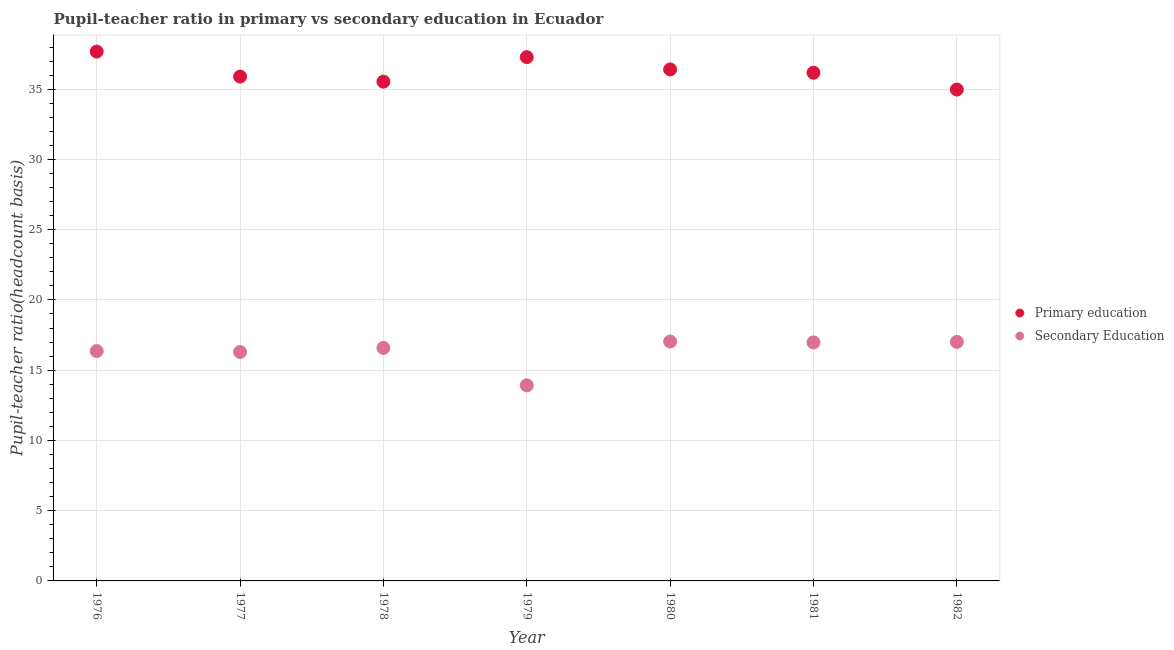Is the number of dotlines equal to the number of legend labels?
Keep it short and to the point. Yes. What is the pupil teacher ratio on secondary education in 1980?
Keep it short and to the point. 17.04. Across all years, what is the maximum pupil teacher ratio on secondary education?
Provide a short and direct response. 17.04. Across all years, what is the minimum pupil-teacher ratio in primary education?
Your response must be concise. 34.98. In which year was the pupil-teacher ratio in primary education maximum?
Offer a very short reply. 1976. In which year was the pupil teacher ratio on secondary education minimum?
Provide a short and direct response. 1979. What is the total pupil teacher ratio on secondary education in the graph?
Make the answer very short. 114.19. What is the difference between the pupil-teacher ratio in primary education in 1977 and that in 1980?
Ensure brevity in your answer.  -0.51. What is the difference between the pupil-teacher ratio in primary education in 1976 and the pupil teacher ratio on secondary education in 1977?
Offer a very short reply. 21.38. What is the average pupil-teacher ratio in primary education per year?
Offer a very short reply. 36.28. In the year 1982, what is the difference between the pupil teacher ratio on secondary education and pupil-teacher ratio in primary education?
Provide a succinct answer. -17.96. What is the ratio of the pupil teacher ratio on secondary education in 1977 to that in 1980?
Offer a very short reply. 0.96. What is the difference between the highest and the second highest pupil teacher ratio on secondary education?
Offer a very short reply. 0.02. What is the difference between the highest and the lowest pupil teacher ratio on secondary education?
Ensure brevity in your answer.  3.12. In how many years, is the pupil-teacher ratio in primary education greater than the average pupil-teacher ratio in primary education taken over all years?
Your answer should be very brief. 3. Is the sum of the pupil teacher ratio on secondary education in 1977 and 1978 greater than the maximum pupil-teacher ratio in primary education across all years?
Offer a terse response. No. Does the pupil-teacher ratio in primary education monotonically increase over the years?
Your answer should be compact. No. Is the pupil teacher ratio on secondary education strictly greater than the pupil-teacher ratio in primary education over the years?
Offer a terse response. No. Is the pupil teacher ratio on secondary education strictly less than the pupil-teacher ratio in primary education over the years?
Your answer should be very brief. Yes. How many dotlines are there?
Provide a short and direct response. 2. What is the difference between two consecutive major ticks on the Y-axis?
Give a very brief answer. 5. Are the values on the major ticks of Y-axis written in scientific E-notation?
Provide a short and direct response. No. How many legend labels are there?
Ensure brevity in your answer.  2. What is the title of the graph?
Your answer should be compact. Pupil-teacher ratio in primary vs secondary education in Ecuador. What is the label or title of the X-axis?
Your answer should be compact. Year. What is the label or title of the Y-axis?
Ensure brevity in your answer.  Pupil-teacher ratio(headcount basis). What is the Pupil-teacher ratio(headcount basis) in Primary education in 1976?
Keep it short and to the point. 37.68. What is the Pupil-teacher ratio(headcount basis) in Secondary Education in 1976?
Provide a short and direct response. 16.36. What is the Pupil-teacher ratio(headcount basis) in Primary education in 1977?
Give a very brief answer. 35.9. What is the Pupil-teacher ratio(headcount basis) of Secondary Education in 1977?
Provide a short and direct response. 16.29. What is the Pupil-teacher ratio(headcount basis) of Primary education in 1978?
Your answer should be very brief. 35.54. What is the Pupil-teacher ratio(headcount basis) of Secondary Education in 1978?
Provide a succinct answer. 16.58. What is the Pupil-teacher ratio(headcount basis) in Primary education in 1979?
Provide a short and direct response. 37.28. What is the Pupil-teacher ratio(headcount basis) in Secondary Education in 1979?
Offer a terse response. 13.92. What is the Pupil-teacher ratio(headcount basis) of Primary education in 1980?
Provide a short and direct response. 36.41. What is the Pupil-teacher ratio(headcount basis) in Secondary Education in 1980?
Keep it short and to the point. 17.04. What is the Pupil-teacher ratio(headcount basis) in Primary education in 1981?
Make the answer very short. 36.17. What is the Pupil-teacher ratio(headcount basis) in Secondary Education in 1981?
Offer a very short reply. 16.98. What is the Pupil-teacher ratio(headcount basis) of Primary education in 1982?
Offer a very short reply. 34.98. What is the Pupil-teacher ratio(headcount basis) of Secondary Education in 1982?
Offer a terse response. 17.01. Across all years, what is the maximum Pupil-teacher ratio(headcount basis) of Primary education?
Provide a succinct answer. 37.68. Across all years, what is the maximum Pupil-teacher ratio(headcount basis) of Secondary Education?
Ensure brevity in your answer.  17.04. Across all years, what is the minimum Pupil-teacher ratio(headcount basis) in Primary education?
Your answer should be very brief. 34.98. Across all years, what is the minimum Pupil-teacher ratio(headcount basis) in Secondary Education?
Provide a short and direct response. 13.92. What is the total Pupil-teacher ratio(headcount basis) of Primary education in the graph?
Make the answer very short. 253.95. What is the total Pupil-teacher ratio(headcount basis) of Secondary Education in the graph?
Offer a terse response. 114.19. What is the difference between the Pupil-teacher ratio(headcount basis) in Primary education in 1976 and that in 1977?
Give a very brief answer. 1.78. What is the difference between the Pupil-teacher ratio(headcount basis) of Secondary Education in 1976 and that in 1977?
Make the answer very short. 0.07. What is the difference between the Pupil-teacher ratio(headcount basis) of Primary education in 1976 and that in 1978?
Provide a short and direct response. 2.14. What is the difference between the Pupil-teacher ratio(headcount basis) in Secondary Education in 1976 and that in 1978?
Your answer should be compact. -0.22. What is the difference between the Pupil-teacher ratio(headcount basis) of Primary education in 1976 and that in 1979?
Keep it short and to the point. 0.4. What is the difference between the Pupil-teacher ratio(headcount basis) of Secondary Education in 1976 and that in 1979?
Your response must be concise. 2.44. What is the difference between the Pupil-teacher ratio(headcount basis) of Primary education in 1976 and that in 1980?
Provide a succinct answer. 1.27. What is the difference between the Pupil-teacher ratio(headcount basis) in Secondary Education in 1976 and that in 1980?
Offer a terse response. -0.68. What is the difference between the Pupil-teacher ratio(headcount basis) in Primary education in 1976 and that in 1981?
Your response must be concise. 1.51. What is the difference between the Pupil-teacher ratio(headcount basis) of Secondary Education in 1976 and that in 1981?
Provide a short and direct response. -0.62. What is the difference between the Pupil-teacher ratio(headcount basis) of Primary education in 1976 and that in 1982?
Your answer should be compact. 2.7. What is the difference between the Pupil-teacher ratio(headcount basis) in Secondary Education in 1976 and that in 1982?
Ensure brevity in your answer.  -0.65. What is the difference between the Pupil-teacher ratio(headcount basis) of Primary education in 1977 and that in 1978?
Make the answer very short. 0.36. What is the difference between the Pupil-teacher ratio(headcount basis) of Secondary Education in 1977 and that in 1978?
Offer a terse response. -0.29. What is the difference between the Pupil-teacher ratio(headcount basis) in Primary education in 1977 and that in 1979?
Keep it short and to the point. -1.38. What is the difference between the Pupil-teacher ratio(headcount basis) of Secondary Education in 1977 and that in 1979?
Your answer should be compact. 2.38. What is the difference between the Pupil-teacher ratio(headcount basis) of Primary education in 1977 and that in 1980?
Your answer should be compact. -0.51. What is the difference between the Pupil-teacher ratio(headcount basis) of Secondary Education in 1977 and that in 1980?
Offer a terse response. -0.74. What is the difference between the Pupil-teacher ratio(headcount basis) of Primary education in 1977 and that in 1981?
Provide a short and direct response. -0.27. What is the difference between the Pupil-teacher ratio(headcount basis) of Secondary Education in 1977 and that in 1981?
Make the answer very short. -0.68. What is the difference between the Pupil-teacher ratio(headcount basis) in Primary education in 1977 and that in 1982?
Give a very brief answer. 0.92. What is the difference between the Pupil-teacher ratio(headcount basis) in Secondary Education in 1977 and that in 1982?
Your answer should be very brief. -0.72. What is the difference between the Pupil-teacher ratio(headcount basis) of Primary education in 1978 and that in 1979?
Ensure brevity in your answer.  -1.74. What is the difference between the Pupil-teacher ratio(headcount basis) in Secondary Education in 1978 and that in 1979?
Ensure brevity in your answer.  2.67. What is the difference between the Pupil-teacher ratio(headcount basis) of Primary education in 1978 and that in 1980?
Provide a short and direct response. -0.87. What is the difference between the Pupil-teacher ratio(headcount basis) in Secondary Education in 1978 and that in 1980?
Give a very brief answer. -0.45. What is the difference between the Pupil-teacher ratio(headcount basis) in Primary education in 1978 and that in 1981?
Provide a succinct answer. -0.64. What is the difference between the Pupil-teacher ratio(headcount basis) in Secondary Education in 1978 and that in 1981?
Provide a succinct answer. -0.39. What is the difference between the Pupil-teacher ratio(headcount basis) in Primary education in 1978 and that in 1982?
Offer a terse response. 0.56. What is the difference between the Pupil-teacher ratio(headcount basis) of Secondary Education in 1978 and that in 1982?
Ensure brevity in your answer.  -0.43. What is the difference between the Pupil-teacher ratio(headcount basis) in Primary education in 1979 and that in 1980?
Make the answer very short. 0.87. What is the difference between the Pupil-teacher ratio(headcount basis) of Secondary Education in 1979 and that in 1980?
Give a very brief answer. -3.12. What is the difference between the Pupil-teacher ratio(headcount basis) in Primary education in 1979 and that in 1981?
Your response must be concise. 1.11. What is the difference between the Pupil-teacher ratio(headcount basis) of Secondary Education in 1979 and that in 1981?
Provide a short and direct response. -3.06. What is the difference between the Pupil-teacher ratio(headcount basis) of Primary education in 1979 and that in 1982?
Your answer should be very brief. 2.3. What is the difference between the Pupil-teacher ratio(headcount basis) of Secondary Education in 1979 and that in 1982?
Ensure brevity in your answer.  -3.09. What is the difference between the Pupil-teacher ratio(headcount basis) of Primary education in 1980 and that in 1981?
Offer a terse response. 0.23. What is the difference between the Pupil-teacher ratio(headcount basis) in Secondary Education in 1980 and that in 1981?
Your response must be concise. 0.06. What is the difference between the Pupil-teacher ratio(headcount basis) in Primary education in 1980 and that in 1982?
Offer a terse response. 1.43. What is the difference between the Pupil-teacher ratio(headcount basis) in Secondary Education in 1980 and that in 1982?
Provide a succinct answer. 0.02. What is the difference between the Pupil-teacher ratio(headcount basis) in Primary education in 1981 and that in 1982?
Keep it short and to the point. 1.2. What is the difference between the Pupil-teacher ratio(headcount basis) of Secondary Education in 1981 and that in 1982?
Ensure brevity in your answer.  -0.04. What is the difference between the Pupil-teacher ratio(headcount basis) of Primary education in 1976 and the Pupil-teacher ratio(headcount basis) of Secondary Education in 1977?
Provide a succinct answer. 21.38. What is the difference between the Pupil-teacher ratio(headcount basis) in Primary education in 1976 and the Pupil-teacher ratio(headcount basis) in Secondary Education in 1978?
Give a very brief answer. 21.09. What is the difference between the Pupil-teacher ratio(headcount basis) of Primary education in 1976 and the Pupil-teacher ratio(headcount basis) of Secondary Education in 1979?
Your answer should be compact. 23.76. What is the difference between the Pupil-teacher ratio(headcount basis) of Primary education in 1976 and the Pupil-teacher ratio(headcount basis) of Secondary Education in 1980?
Keep it short and to the point. 20.64. What is the difference between the Pupil-teacher ratio(headcount basis) in Primary education in 1976 and the Pupil-teacher ratio(headcount basis) in Secondary Education in 1981?
Provide a short and direct response. 20.7. What is the difference between the Pupil-teacher ratio(headcount basis) of Primary education in 1976 and the Pupil-teacher ratio(headcount basis) of Secondary Education in 1982?
Offer a very short reply. 20.66. What is the difference between the Pupil-teacher ratio(headcount basis) of Primary education in 1977 and the Pupil-teacher ratio(headcount basis) of Secondary Education in 1978?
Offer a very short reply. 19.31. What is the difference between the Pupil-teacher ratio(headcount basis) in Primary education in 1977 and the Pupil-teacher ratio(headcount basis) in Secondary Education in 1979?
Give a very brief answer. 21.98. What is the difference between the Pupil-teacher ratio(headcount basis) of Primary education in 1977 and the Pupil-teacher ratio(headcount basis) of Secondary Education in 1980?
Your answer should be compact. 18.86. What is the difference between the Pupil-teacher ratio(headcount basis) of Primary education in 1977 and the Pupil-teacher ratio(headcount basis) of Secondary Education in 1981?
Your answer should be compact. 18.92. What is the difference between the Pupil-teacher ratio(headcount basis) of Primary education in 1977 and the Pupil-teacher ratio(headcount basis) of Secondary Education in 1982?
Your answer should be very brief. 18.88. What is the difference between the Pupil-teacher ratio(headcount basis) of Primary education in 1978 and the Pupil-teacher ratio(headcount basis) of Secondary Education in 1979?
Your response must be concise. 21.62. What is the difference between the Pupil-teacher ratio(headcount basis) in Primary education in 1978 and the Pupil-teacher ratio(headcount basis) in Secondary Education in 1980?
Your answer should be very brief. 18.5. What is the difference between the Pupil-teacher ratio(headcount basis) in Primary education in 1978 and the Pupil-teacher ratio(headcount basis) in Secondary Education in 1981?
Ensure brevity in your answer.  18.56. What is the difference between the Pupil-teacher ratio(headcount basis) of Primary education in 1978 and the Pupil-teacher ratio(headcount basis) of Secondary Education in 1982?
Offer a terse response. 18.52. What is the difference between the Pupil-teacher ratio(headcount basis) in Primary education in 1979 and the Pupil-teacher ratio(headcount basis) in Secondary Education in 1980?
Ensure brevity in your answer.  20.24. What is the difference between the Pupil-teacher ratio(headcount basis) of Primary education in 1979 and the Pupil-teacher ratio(headcount basis) of Secondary Education in 1981?
Offer a terse response. 20.3. What is the difference between the Pupil-teacher ratio(headcount basis) of Primary education in 1979 and the Pupil-teacher ratio(headcount basis) of Secondary Education in 1982?
Offer a terse response. 20.27. What is the difference between the Pupil-teacher ratio(headcount basis) of Primary education in 1980 and the Pupil-teacher ratio(headcount basis) of Secondary Education in 1981?
Provide a succinct answer. 19.43. What is the difference between the Pupil-teacher ratio(headcount basis) in Primary education in 1980 and the Pupil-teacher ratio(headcount basis) in Secondary Education in 1982?
Provide a succinct answer. 19.39. What is the difference between the Pupil-teacher ratio(headcount basis) of Primary education in 1981 and the Pupil-teacher ratio(headcount basis) of Secondary Education in 1982?
Ensure brevity in your answer.  19.16. What is the average Pupil-teacher ratio(headcount basis) in Primary education per year?
Offer a very short reply. 36.28. What is the average Pupil-teacher ratio(headcount basis) in Secondary Education per year?
Your response must be concise. 16.31. In the year 1976, what is the difference between the Pupil-teacher ratio(headcount basis) of Primary education and Pupil-teacher ratio(headcount basis) of Secondary Education?
Provide a succinct answer. 21.32. In the year 1977, what is the difference between the Pupil-teacher ratio(headcount basis) of Primary education and Pupil-teacher ratio(headcount basis) of Secondary Education?
Provide a short and direct response. 19.6. In the year 1978, what is the difference between the Pupil-teacher ratio(headcount basis) in Primary education and Pupil-teacher ratio(headcount basis) in Secondary Education?
Offer a terse response. 18.95. In the year 1979, what is the difference between the Pupil-teacher ratio(headcount basis) of Primary education and Pupil-teacher ratio(headcount basis) of Secondary Education?
Provide a short and direct response. 23.36. In the year 1980, what is the difference between the Pupil-teacher ratio(headcount basis) in Primary education and Pupil-teacher ratio(headcount basis) in Secondary Education?
Offer a very short reply. 19.37. In the year 1981, what is the difference between the Pupil-teacher ratio(headcount basis) in Primary education and Pupil-teacher ratio(headcount basis) in Secondary Education?
Your response must be concise. 19.2. In the year 1982, what is the difference between the Pupil-teacher ratio(headcount basis) of Primary education and Pupil-teacher ratio(headcount basis) of Secondary Education?
Offer a terse response. 17.96. What is the ratio of the Pupil-teacher ratio(headcount basis) in Primary education in 1976 to that in 1977?
Ensure brevity in your answer.  1.05. What is the ratio of the Pupil-teacher ratio(headcount basis) in Primary education in 1976 to that in 1978?
Give a very brief answer. 1.06. What is the ratio of the Pupil-teacher ratio(headcount basis) of Secondary Education in 1976 to that in 1978?
Give a very brief answer. 0.99. What is the ratio of the Pupil-teacher ratio(headcount basis) of Primary education in 1976 to that in 1979?
Your response must be concise. 1.01. What is the ratio of the Pupil-teacher ratio(headcount basis) in Secondary Education in 1976 to that in 1979?
Your answer should be compact. 1.18. What is the ratio of the Pupil-teacher ratio(headcount basis) of Primary education in 1976 to that in 1980?
Make the answer very short. 1.03. What is the ratio of the Pupil-teacher ratio(headcount basis) of Secondary Education in 1976 to that in 1980?
Offer a very short reply. 0.96. What is the ratio of the Pupil-teacher ratio(headcount basis) of Primary education in 1976 to that in 1981?
Your answer should be very brief. 1.04. What is the ratio of the Pupil-teacher ratio(headcount basis) of Secondary Education in 1976 to that in 1981?
Your answer should be compact. 0.96. What is the ratio of the Pupil-teacher ratio(headcount basis) of Primary education in 1976 to that in 1982?
Offer a terse response. 1.08. What is the ratio of the Pupil-teacher ratio(headcount basis) in Secondary Education in 1976 to that in 1982?
Your answer should be very brief. 0.96. What is the ratio of the Pupil-teacher ratio(headcount basis) of Primary education in 1977 to that in 1978?
Offer a terse response. 1.01. What is the ratio of the Pupil-teacher ratio(headcount basis) of Secondary Education in 1977 to that in 1978?
Make the answer very short. 0.98. What is the ratio of the Pupil-teacher ratio(headcount basis) in Primary education in 1977 to that in 1979?
Make the answer very short. 0.96. What is the ratio of the Pupil-teacher ratio(headcount basis) in Secondary Education in 1977 to that in 1979?
Ensure brevity in your answer.  1.17. What is the ratio of the Pupil-teacher ratio(headcount basis) in Primary education in 1977 to that in 1980?
Provide a succinct answer. 0.99. What is the ratio of the Pupil-teacher ratio(headcount basis) of Secondary Education in 1977 to that in 1980?
Keep it short and to the point. 0.96. What is the ratio of the Pupil-teacher ratio(headcount basis) of Primary education in 1977 to that in 1981?
Your answer should be very brief. 0.99. What is the ratio of the Pupil-teacher ratio(headcount basis) of Secondary Education in 1977 to that in 1981?
Provide a short and direct response. 0.96. What is the ratio of the Pupil-teacher ratio(headcount basis) in Primary education in 1977 to that in 1982?
Give a very brief answer. 1.03. What is the ratio of the Pupil-teacher ratio(headcount basis) in Secondary Education in 1977 to that in 1982?
Provide a succinct answer. 0.96. What is the ratio of the Pupil-teacher ratio(headcount basis) in Primary education in 1978 to that in 1979?
Make the answer very short. 0.95. What is the ratio of the Pupil-teacher ratio(headcount basis) in Secondary Education in 1978 to that in 1979?
Your answer should be compact. 1.19. What is the ratio of the Pupil-teacher ratio(headcount basis) of Primary education in 1978 to that in 1980?
Give a very brief answer. 0.98. What is the ratio of the Pupil-teacher ratio(headcount basis) of Secondary Education in 1978 to that in 1980?
Your answer should be very brief. 0.97. What is the ratio of the Pupil-teacher ratio(headcount basis) of Primary education in 1978 to that in 1981?
Ensure brevity in your answer.  0.98. What is the ratio of the Pupil-teacher ratio(headcount basis) in Secondary Education in 1978 to that in 1981?
Keep it short and to the point. 0.98. What is the ratio of the Pupil-teacher ratio(headcount basis) in Primary education in 1978 to that in 1982?
Offer a very short reply. 1.02. What is the ratio of the Pupil-teacher ratio(headcount basis) in Secondary Education in 1978 to that in 1982?
Keep it short and to the point. 0.97. What is the ratio of the Pupil-teacher ratio(headcount basis) of Primary education in 1979 to that in 1980?
Offer a terse response. 1.02. What is the ratio of the Pupil-teacher ratio(headcount basis) of Secondary Education in 1979 to that in 1980?
Give a very brief answer. 0.82. What is the ratio of the Pupil-teacher ratio(headcount basis) of Primary education in 1979 to that in 1981?
Offer a very short reply. 1.03. What is the ratio of the Pupil-teacher ratio(headcount basis) in Secondary Education in 1979 to that in 1981?
Ensure brevity in your answer.  0.82. What is the ratio of the Pupil-teacher ratio(headcount basis) of Primary education in 1979 to that in 1982?
Your response must be concise. 1.07. What is the ratio of the Pupil-teacher ratio(headcount basis) of Secondary Education in 1979 to that in 1982?
Your response must be concise. 0.82. What is the ratio of the Pupil-teacher ratio(headcount basis) of Primary education in 1980 to that in 1981?
Make the answer very short. 1.01. What is the ratio of the Pupil-teacher ratio(headcount basis) of Secondary Education in 1980 to that in 1981?
Keep it short and to the point. 1. What is the ratio of the Pupil-teacher ratio(headcount basis) in Primary education in 1980 to that in 1982?
Ensure brevity in your answer.  1.04. What is the ratio of the Pupil-teacher ratio(headcount basis) in Primary education in 1981 to that in 1982?
Offer a very short reply. 1.03. What is the ratio of the Pupil-teacher ratio(headcount basis) in Secondary Education in 1981 to that in 1982?
Your answer should be very brief. 1. What is the difference between the highest and the second highest Pupil-teacher ratio(headcount basis) of Primary education?
Your answer should be compact. 0.4. What is the difference between the highest and the second highest Pupil-teacher ratio(headcount basis) of Secondary Education?
Your answer should be compact. 0.02. What is the difference between the highest and the lowest Pupil-teacher ratio(headcount basis) of Primary education?
Your answer should be compact. 2.7. What is the difference between the highest and the lowest Pupil-teacher ratio(headcount basis) in Secondary Education?
Your answer should be very brief. 3.12. 